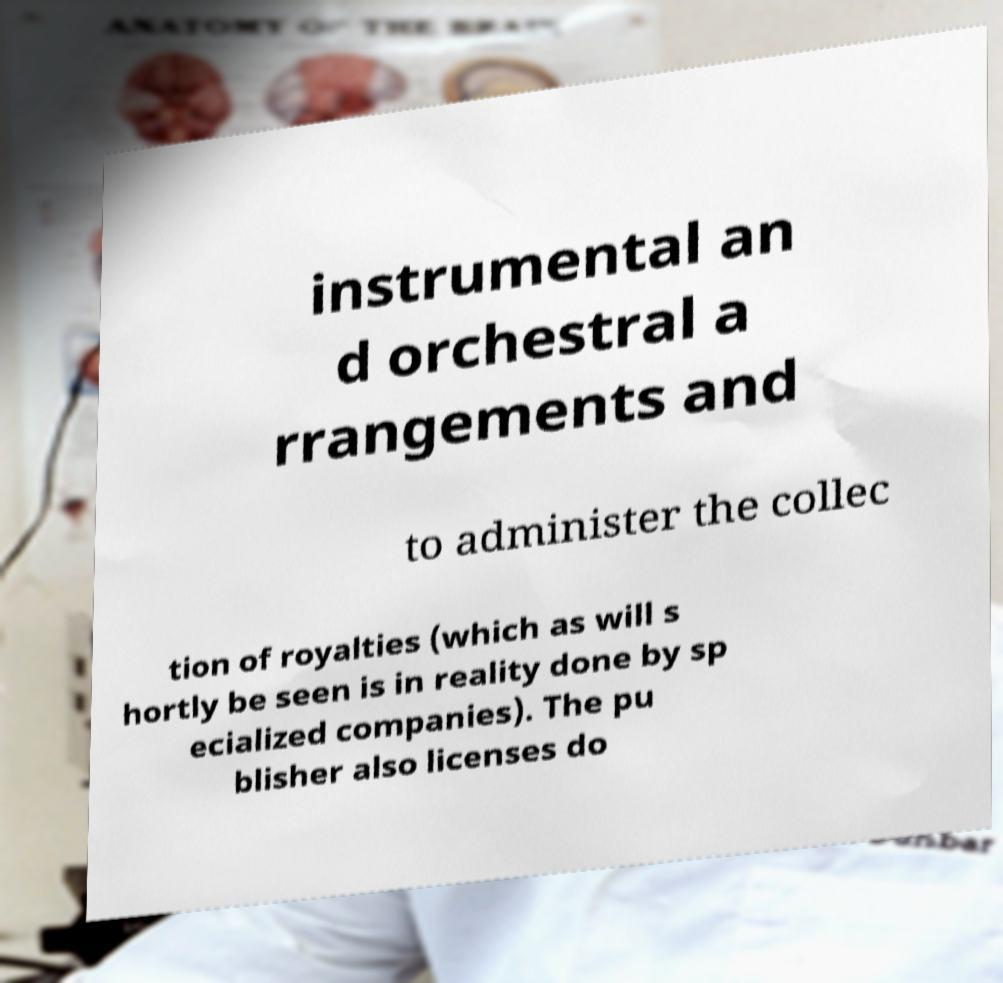What messages or text are displayed in this image? I need them in a readable, typed format. instrumental an d orchestral a rrangements and to administer the collec tion of royalties (which as will s hortly be seen is in reality done by sp ecialized companies). The pu blisher also licenses do 